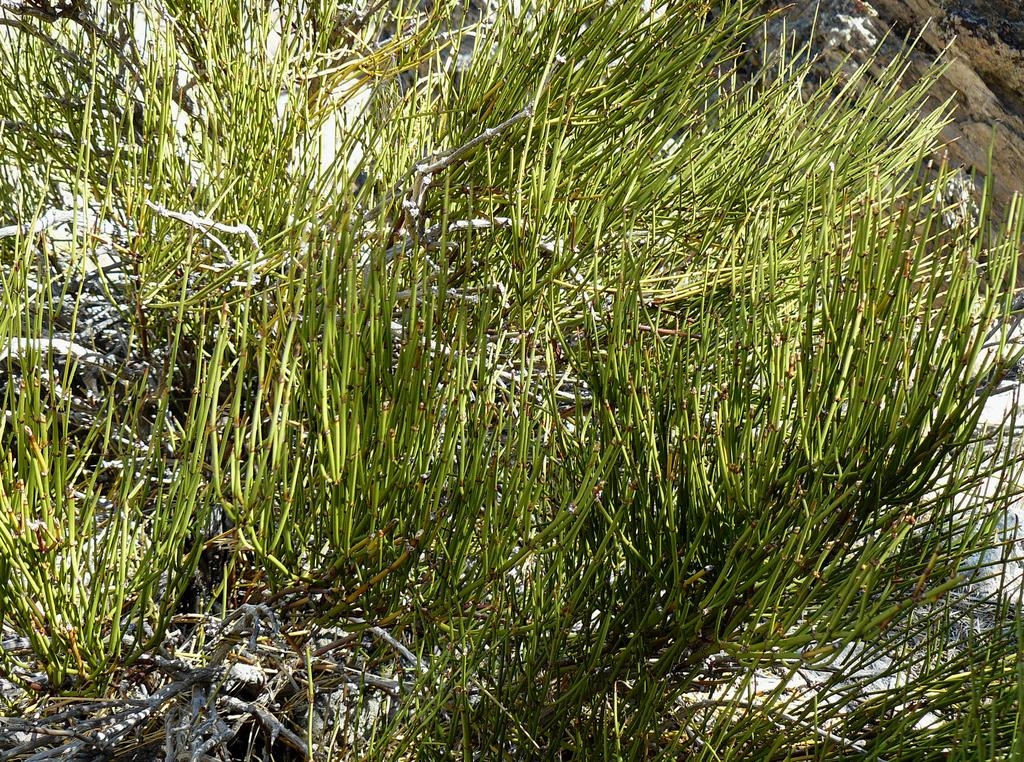What type of vegetation is present in the image? There is grass in the image. What other objects can be seen in the image besides the grass? There are sticks in the image. Can you describe the brown-colored object in the top right corner of the image? There is a brown-colored object in the top right corner of the image. What type of work is being done by the rod in the image? There is no rod present in the image, and therefore no work is being done by a rod. What arithmetic problem can be solved using the sticks in the image? There is no arithmetic problem present in the image, and the sticks are not used for solving mathematical problems. 